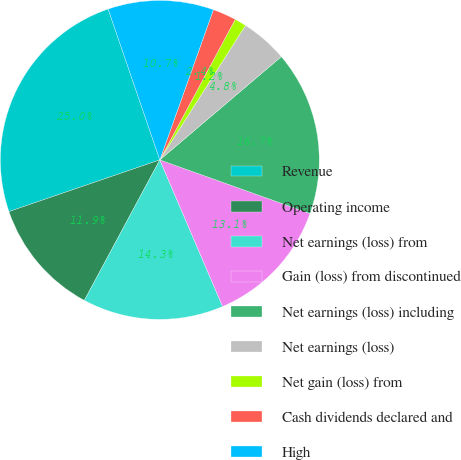<chart> <loc_0><loc_0><loc_500><loc_500><pie_chart><fcel>Revenue<fcel>Operating income<fcel>Net earnings (loss) from<fcel>Gain (loss) from discontinued<fcel>Net earnings (loss) including<fcel>Net earnings (loss)<fcel>Net gain (loss) from<fcel>Cash dividends declared and<fcel>High<nl><fcel>25.0%<fcel>11.9%<fcel>14.29%<fcel>13.1%<fcel>16.67%<fcel>4.76%<fcel>1.19%<fcel>2.38%<fcel>10.71%<nl></chart> 